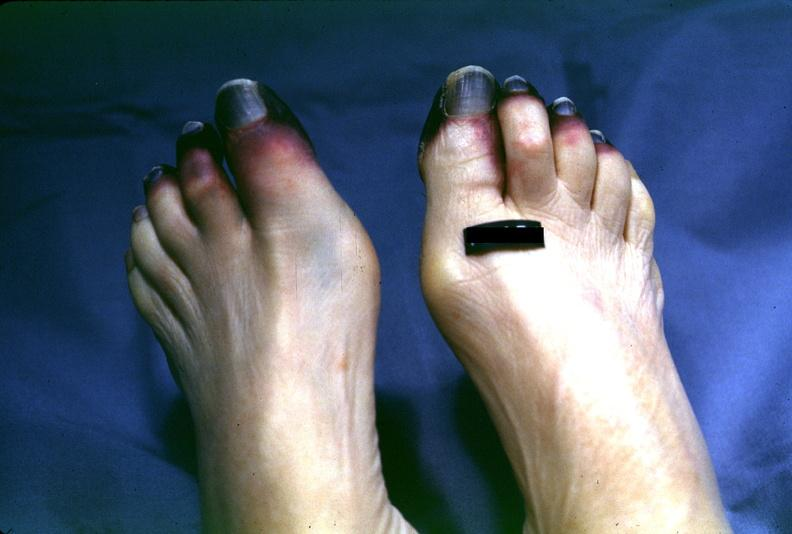re section of both kidneys and adrenals present?
Answer the question using a single word or phrase. No 